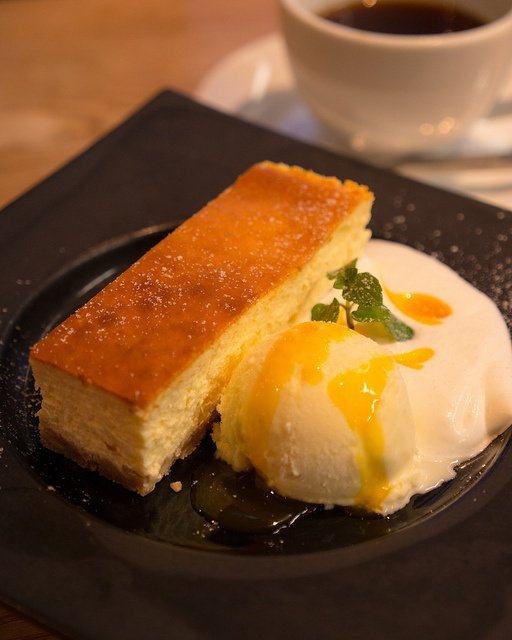Describe the objects in this image and their specific colors. I can see dining table in maroon, black, and gray tones, cake in maroon, red, brown, and orange tones, cup in maroon, gray, tan, and brown tones, spoon in maroon, gray, and tan tones, and spoon in maroon, gray, tan, and brown tones in this image. 